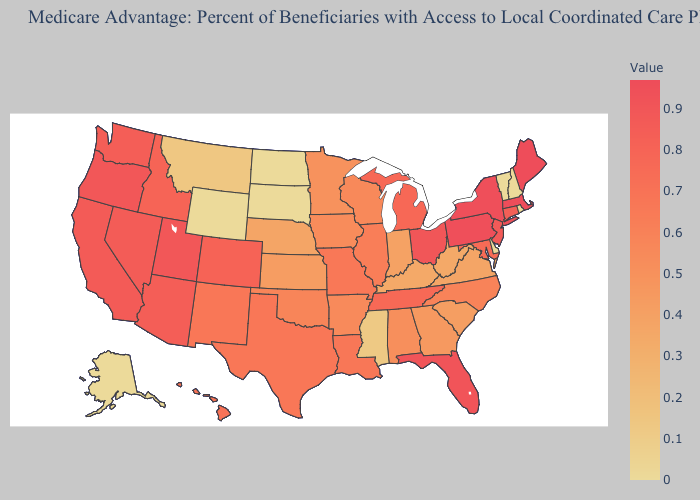Among the states that border Louisiana , does Texas have the highest value?
Keep it brief. Yes. Does Rhode Island have the lowest value in the USA?
Concise answer only. Yes. Among the states that border Oregon , does Nevada have the lowest value?
Give a very brief answer. No. Does the map have missing data?
Be succinct. No. Which states have the lowest value in the USA?
Short answer required. Alaska, Delaware, North Dakota, New Hampshire, Rhode Island, South Dakota, Vermont, Wyoming. Which states have the lowest value in the West?
Short answer required. Alaska, Wyoming. Does Ohio have the lowest value in the USA?
Give a very brief answer. No. 